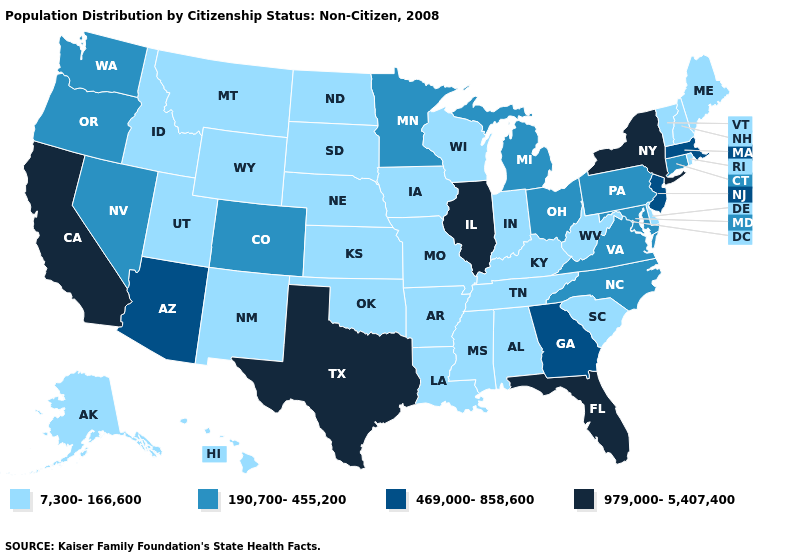What is the value of Oregon?
Concise answer only. 190,700-455,200. What is the value of West Virginia?
Concise answer only. 7,300-166,600. What is the value of Idaho?
Give a very brief answer. 7,300-166,600. Which states have the lowest value in the Northeast?
Answer briefly. Maine, New Hampshire, Rhode Island, Vermont. Is the legend a continuous bar?
Give a very brief answer. No. What is the value of West Virginia?
Concise answer only. 7,300-166,600. Does South Dakota have a lower value than Illinois?
Short answer required. Yes. Does New York have the highest value in the USA?
Concise answer only. Yes. What is the lowest value in the West?
Concise answer only. 7,300-166,600. Name the states that have a value in the range 469,000-858,600?
Quick response, please. Arizona, Georgia, Massachusetts, New Jersey. What is the value of South Carolina?
Quick response, please. 7,300-166,600. Which states hav the highest value in the West?
Give a very brief answer. California. Which states hav the highest value in the South?
Concise answer only. Florida, Texas. Does Rhode Island have a lower value than Utah?
Write a very short answer. No. Among the states that border New Jersey , does Pennsylvania have the highest value?
Give a very brief answer. No. 